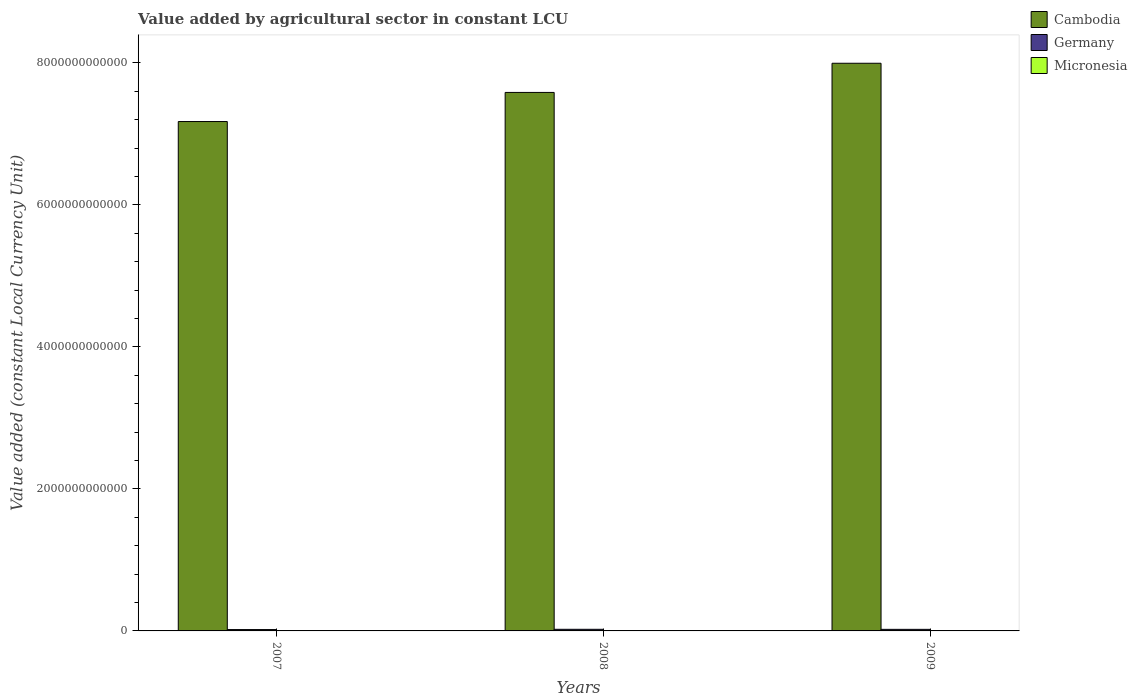How many different coloured bars are there?
Give a very brief answer. 3. Are the number of bars per tick equal to the number of legend labels?
Make the answer very short. Yes. How many bars are there on the 2nd tick from the right?
Make the answer very short. 3. What is the label of the 3rd group of bars from the left?
Provide a succinct answer. 2009. What is the value added by agricultural sector in Cambodia in 2008?
Offer a terse response. 7.58e+12. Across all years, what is the maximum value added by agricultural sector in Micronesia?
Give a very brief answer. 5.75e+07. Across all years, what is the minimum value added by agricultural sector in Germany?
Provide a short and direct response. 1.90e+1. What is the total value added by agricultural sector in Micronesia in the graph?
Provide a short and direct response. 1.72e+08. What is the difference between the value added by agricultural sector in Germany in 2007 and that in 2008?
Provide a succinct answer. -3.82e+09. What is the difference between the value added by agricultural sector in Micronesia in 2008 and the value added by agricultural sector in Cambodia in 2009?
Offer a terse response. -7.99e+12. What is the average value added by agricultural sector in Micronesia per year?
Your answer should be compact. 5.73e+07. In the year 2008, what is the difference between the value added by agricultural sector in Micronesia and value added by agricultural sector in Germany?
Keep it short and to the point. -2.28e+1. In how many years, is the value added by agricultural sector in Micronesia greater than 7600000000000 LCU?
Your answer should be compact. 0. What is the ratio of the value added by agricultural sector in Micronesia in 2007 to that in 2009?
Provide a short and direct response. 1.01. Is the value added by agricultural sector in Cambodia in 2008 less than that in 2009?
Your answer should be very brief. Yes. Is the difference between the value added by agricultural sector in Micronesia in 2007 and 2009 greater than the difference between the value added by agricultural sector in Germany in 2007 and 2009?
Your answer should be compact. Yes. What is the difference between the highest and the second highest value added by agricultural sector in Cambodia?
Your response must be concise. 4.11e+11. What is the difference between the highest and the lowest value added by agricultural sector in Germany?
Your answer should be very brief. 3.82e+09. In how many years, is the value added by agricultural sector in Micronesia greater than the average value added by agricultural sector in Micronesia taken over all years?
Offer a very short reply. 2. What does the 2nd bar from the left in 2007 represents?
Keep it short and to the point. Germany. What does the 2nd bar from the right in 2009 represents?
Provide a short and direct response. Germany. How many years are there in the graph?
Your answer should be very brief. 3. What is the difference between two consecutive major ticks on the Y-axis?
Your answer should be very brief. 2.00e+12. Are the values on the major ticks of Y-axis written in scientific E-notation?
Offer a terse response. No. Where does the legend appear in the graph?
Offer a terse response. Top right. What is the title of the graph?
Give a very brief answer. Value added by agricultural sector in constant LCU. Does "Europe(all income levels)" appear as one of the legend labels in the graph?
Keep it short and to the point. No. What is the label or title of the X-axis?
Your answer should be compact. Years. What is the label or title of the Y-axis?
Provide a succinct answer. Value added (constant Local Currency Unit). What is the Value added (constant Local Currency Unit) in Cambodia in 2007?
Ensure brevity in your answer.  7.17e+12. What is the Value added (constant Local Currency Unit) in Germany in 2007?
Offer a very short reply. 1.90e+1. What is the Value added (constant Local Currency Unit) of Micronesia in 2007?
Offer a very short reply. 5.75e+07. What is the Value added (constant Local Currency Unit) of Cambodia in 2008?
Offer a very short reply. 7.58e+12. What is the Value added (constant Local Currency Unit) in Germany in 2008?
Offer a terse response. 2.28e+1. What is the Value added (constant Local Currency Unit) in Micronesia in 2008?
Your answer should be very brief. 5.74e+07. What is the Value added (constant Local Currency Unit) in Cambodia in 2009?
Your response must be concise. 7.99e+12. What is the Value added (constant Local Currency Unit) of Germany in 2009?
Give a very brief answer. 2.21e+1. What is the Value added (constant Local Currency Unit) in Micronesia in 2009?
Keep it short and to the point. 5.69e+07. Across all years, what is the maximum Value added (constant Local Currency Unit) of Cambodia?
Offer a terse response. 7.99e+12. Across all years, what is the maximum Value added (constant Local Currency Unit) of Germany?
Ensure brevity in your answer.  2.28e+1. Across all years, what is the maximum Value added (constant Local Currency Unit) in Micronesia?
Offer a terse response. 5.75e+07. Across all years, what is the minimum Value added (constant Local Currency Unit) in Cambodia?
Offer a very short reply. 7.17e+12. Across all years, what is the minimum Value added (constant Local Currency Unit) in Germany?
Offer a very short reply. 1.90e+1. Across all years, what is the minimum Value added (constant Local Currency Unit) of Micronesia?
Provide a short and direct response. 5.69e+07. What is the total Value added (constant Local Currency Unit) of Cambodia in the graph?
Provide a short and direct response. 2.28e+13. What is the total Value added (constant Local Currency Unit) of Germany in the graph?
Provide a short and direct response. 6.39e+1. What is the total Value added (constant Local Currency Unit) in Micronesia in the graph?
Offer a terse response. 1.72e+08. What is the difference between the Value added (constant Local Currency Unit) in Cambodia in 2007 and that in 2008?
Your response must be concise. -4.10e+11. What is the difference between the Value added (constant Local Currency Unit) in Germany in 2007 and that in 2008?
Provide a succinct answer. -3.82e+09. What is the difference between the Value added (constant Local Currency Unit) of Micronesia in 2007 and that in 2008?
Make the answer very short. 1.00e+05. What is the difference between the Value added (constant Local Currency Unit) in Cambodia in 2007 and that in 2009?
Your response must be concise. -8.21e+11. What is the difference between the Value added (constant Local Currency Unit) in Germany in 2007 and that in 2009?
Your response must be concise. -3.07e+09. What is the difference between the Value added (constant Local Currency Unit) of Cambodia in 2008 and that in 2009?
Offer a terse response. -4.11e+11. What is the difference between the Value added (constant Local Currency Unit) in Germany in 2008 and that in 2009?
Your answer should be compact. 7.46e+08. What is the difference between the Value added (constant Local Currency Unit) in Micronesia in 2008 and that in 2009?
Provide a short and direct response. 5.00e+05. What is the difference between the Value added (constant Local Currency Unit) in Cambodia in 2007 and the Value added (constant Local Currency Unit) in Germany in 2008?
Your response must be concise. 7.15e+12. What is the difference between the Value added (constant Local Currency Unit) of Cambodia in 2007 and the Value added (constant Local Currency Unit) of Micronesia in 2008?
Make the answer very short. 7.17e+12. What is the difference between the Value added (constant Local Currency Unit) of Germany in 2007 and the Value added (constant Local Currency Unit) of Micronesia in 2008?
Make the answer very short. 1.90e+1. What is the difference between the Value added (constant Local Currency Unit) of Cambodia in 2007 and the Value added (constant Local Currency Unit) of Germany in 2009?
Your answer should be very brief. 7.15e+12. What is the difference between the Value added (constant Local Currency Unit) in Cambodia in 2007 and the Value added (constant Local Currency Unit) in Micronesia in 2009?
Ensure brevity in your answer.  7.17e+12. What is the difference between the Value added (constant Local Currency Unit) of Germany in 2007 and the Value added (constant Local Currency Unit) of Micronesia in 2009?
Your response must be concise. 1.90e+1. What is the difference between the Value added (constant Local Currency Unit) of Cambodia in 2008 and the Value added (constant Local Currency Unit) of Germany in 2009?
Provide a succinct answer. 7.56e+12. What is the difference between the Value added (constant Local Currency Unit) of Cambodia in 2008 and the Value added (constant Local Currency Unit) of Micronesia in 2009?
Your answer should be very brief. 7.58e+12. What is the difference between the Value added (constant Local Currency Unit) in Germany in 2008 and the Value added (constant Local Currency Unit) in Micronesia in 2009?
Give a very brief answer. 2.28e+1. What is the average Value added (constant Local Currency Unit) in Cambodia per year?
Your answer should be compact. 7.58e+12. What is the average Value added (constant Local Currency Unit) of Germany per year?
Keep it short and to the point. 2.13e+1. What is the average Value added (constant Local Currency Unit) in Micronesia per year?
Your response must be concise. 5.73e+07. In the year 2007, what is the difference between the Value added (constant Local Currency Unit) of Cambodia and Value added (constant Local Currency Unit) of Germany?
Provide a short and direct response. 7.15e+12. In the year 2007, what is the difference between the Value added (constant Local Currency Unit) in Cambodia and Value added (constant Local Currency Unit) in Micronesia?
Your response must be concise. 7.17e+12. In the year 2007, what is the difference between the Value added (constant Local Currency Unit) in Germany and Value added (constant Local Currency Unit) in Micronesia?
Offer a very short reply. 1.90e+1. In the year 2008, what is the difference between the Value added (constant Local Currency Unit) of Cambodia and Value added (constant Local Currency Unit) of Germany?
Offer a very short reply. 7.56e+12. In the year 2008, what is the difference between the Value added (constant Local Currency Unit) in Cambodia and Value added (constant Local Currency Unit) in Micronesia?
Ensure brevity in your answer.  7.58e+12. In the year 2008, what is the difference between the Value added (constant Local Currency Unit) in Germany and Value added (constant Local Currency Unit) in Micronesia?
Provide a succinct answer. 2.28e+1. In the year 2009, what is the difference between the Value added (constant Local Currency Unit) in Cambodia and Value added (constant Local Currency Unit) in Germany?
Offer a very short reply. 7.97e+12. In the year 2009, what is the difference between the Value added (constant Local Currency Unit) in Cambodia and Value added (constant Local Currency Unit) in Micronesia?
Keep it short and to the point. 7.99e+12. In the year 2009, what is the difference between the Value added (constant Local Currency Unit) of Germany and Value added (constant Local Currency Unit) of Micronesia?
Offer a very short reply. 2.20e+1. What is the ratio of the Value added (constant Local Currency Unit) of Cambodia in 2007 to that in 2008?
Provide a succinct answer. 0.95. What is the ratio of the Value added (constant Local Currency Unit) in Germany in 2007 to that in 2008?
Give a very brief answer. 0.83. What is the ratio of the Value added (constant Local Currency Unit) in Micronesia in 2007 to that in 2008?
Give a very brief answer. 1. What is the ratio of the Value added (constant Local Currency Unit) of Cambodia in 2007 to that in 2009?
Ensure brevity in your answer.  0.9. What is the ratio of the Value added (constant Local Currency Unit) in Germany in 2007 to that in 2009?
Offer a terse response. 0.86. What is the ratio of the Value added (constant Local Currency Unit) of Micronesia in 2007 to that in 2009?
Provide a succinct answer. 1.01. What is the ratio of the Value added (constant Local Currency Unit) in Cambodia in 2008 to that in 2009?
Your response must be concise. 0.95. What is the ratio of the Value added (constant Local Currency Unit) of Germany in 2008 to that in 2009?
Provide a succinct answer. 1.03. What is the ratio of the Value added (constant Local Currency Unit) of Micronesia in 2008 to that in 2009?
Your answer should be compact. 1.01. What is the difference between the highest and the second highest Value added (constant Local Currency Unit) in Cambodia?
Your response must be concise. 4.11e+11. What is the difference between the highest and the second highest Value added (constant Local Currency Unit) in Germany?
Your answer should be very brief. 7.46e+08. What is the difference between the highest and the lowest Value added (constant Local Currency Unit) of Cambodia?
Offer a terse response. 8.21e+11. What is the difference between the highest and the lowest Value added (constant Local Currency Unit) in Germany?
Your answer should be very brief. 3.82e+09. 